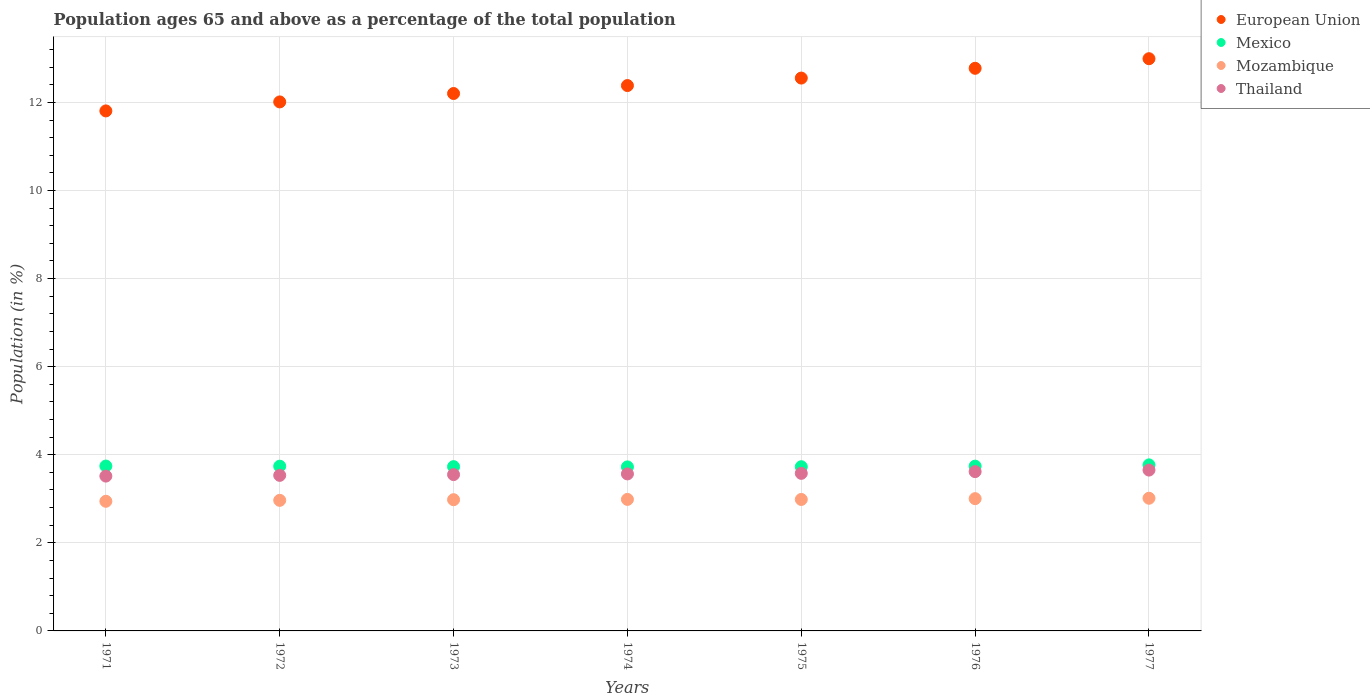What is the percentage of the population ages 65 and above in Thailand in 1971?
Give a very brief answer. 3.52. Across all years, what is the maximum percentage of the population ages 65 and above in Mozambique?
Give a very brief answer. 3.01. Across all years, what is the minimum percentage of the population ages 65 and above in Mozambique?
Ensure brevity in your answer.  2.94. In which year was the percentage of the population ages 65 and above in European Union maximum?
Make the answer very short. 1977. What is the total percentage of the population ages 65 and above in European Union in the graph?
Ensure brevity in your answer.  86.72. What is the difference between the percentage of the population ages 65 and above in Mexico in 1971 and that in 1976?
Keep it short and to the point. 0. What is the difference between the percentage of the population ages 65 and above in Mexico in 1973 and the percentage of the population ages 65 and above in Thailand in 1974?
Provide a succinct answer. 0.17. What is the average percentage of the population ages 65 and above in European Union per year?
Provide a succinct answer. 12.39. In the year 1971, what is the difference between the percentage of the population ages 65 and above in European Union and percentage of the population ages 65 and above in Thailand?
Offer a very short reply. 8.29. In how many years, is the percentage of the population ages 65 and above in European Union greater than 5.6?
Provide a succinct answer. 7. What is the ratio of the percentage of the population ages 65 and above in Mozambique in 1971 to that in 1977?
Your answer should be very brief. 0.98. Is the percentage of the population ages 65 and above in Mozambique in 1971 less than that in 1972?
Keep it short and to the point. Yes. What is the difference between the highest and the second highest percentage of the population ages 65 and above in Thailand?
Offer a terse response. 0.03. What is the difference between the highest and the lowest percentage of the population ages 65 and above in European Union?
Make the answer very short. 1.19. In how many years, is the percentage of the population ages 65 and above in Thailand greater than the average percentage of the population ages 65 and above in Thailand taken over all years?
Your response must be concise. 3. Is the percentage of the population ages 65 and above in Thailand strictly greater than the percentage of the population ages 65 and above in European Union over the years?
Give a very brief answer. No. Is the percentage of the population ages 65 and above in European Union strictly less than the percentage of the population ages 65 and above in Mozambique over the years?
Your answer should be compact. No. How many years are there in the graph?
Your response must be concise. 7. What is the difference between two consecutive major ticks on the Y-axis?
Provide a short and direct response. 2. Are the values on the major ticks of Y-axis written in scientific E-notation?
Your answer should be very brief. No. Does the graph contain grids?
Offer a very short reply. Yes. Where does the legend appear in the graph?
Ensure brevity in your answer.  Top right. How many legend labels are there?
Give a very brief answer. 4. How are the legend labels stacked?
Your answer should be compact. Vertical. What is the title of the graph?
Give a very brief answer. Population ages 65 and above as a percentage of the total population. Does "Macedonia" appear as one of the legend labels in the graph?
Make the answer very short. No. What is the Population (in %) of European Union in 1971?
Give a very brief answer. 11.81. What is the Population (in %) in Mexico in 1971?
Your answer should be compact. 3.74. What is the Population (in %) in Mozambique in 1971?
Your response must be concise. 2.94. What is the Population (in %) of Thailand in 1971?
Your answer should be compact. 3.52. What is the Population (in %) in European Union in 1972?
Make the answer very short. 12.01. What is the Population (in %) in Mexico in 1972?
Your answer should be very brief. 3.74. What is the Population (in %) in Mozambique in 1972?
Ensure brevity in your answer.  2.96. What is the Population (in %) of Thailand in 1972?
Your response must be concise. 3.53. What is the Population (in %) in European Union in 1973?
Your response must be concise. 12.2. What is the Population (in %) in Mexico in 1973?
Offer a terse response. 3.73. What is the Population (in %) of Mozambique in 1973?
Ensure brevity in your answer.  2.98. What is the Population (in %) of Thailand in 1973?
Keep it short and to the point. 3.55. What is the Population (in %) in European Union in 1974?
Your answer should be compact. 12.38. What is the Population (in %) of Mexico in 1974?
Provide a short and direct response. 3.72. What is the Population (in %) in Mozambique in 1974?
Ensure brevity in your answer.  2.99. What is the Population (in %) of Thailand in 1974?
Your answer should be very brief. 3.56. What is the Population (in %) in European Union in 1975?
Your answer should be compact. 12.55. What is the Population (in %) in Mexico in 1975?
Offer a very short reply. 3.73. What is the Population (in %) of Mozambique in 1975?
Ensure brevity in your answer.  2.99. What is the Population (in %) in Thailand in 1975?
Make the answer very short. 3.58. What is the Population (in %) in European Union in 1976?
Ensure brevity in your answer.  12.77. What is the Population (in %) in Mexico in 1976?
Offer a terse response. 3.74. What is the Population (in %) in Mozambique in 1976?
Provide a succinct answer. 3. What is the Population (in %) of Thailand in 1976?
Offer a terse response. 3.62. What is the Population (in %) of European Union in 1977?
Provide a short and direct response. 12.99. What is the Population (in %) of Mexico in 1977?
Give a very brief answer. 3.77. What is the Population (in %) in Mozambique in 1977?
Offer a terse response. 3.01. What is the Population (in %) of Thailand in 1977?
Your answer should be compact. 3.65. Across all years, what is the maximum Population (in %) in European Union?
Provide a succinct answer. 12.99. Across all years, what is the maximum Population (in %) in Mexico?
Your answer should be compact. 3.77. Across all years, what is the maximum Population (in %) in Mozambique?
Ensure brevity in your answer.  3.01. Across all years, what is the maximum Population (in %) of Thailand?
Your response must be concise. 3.65. Across all years, what is the minimum Population (in %) of European Union?
Your answer should be very brief. 11.81. Across all years, what is the minimum Population (in %) of Mexico?
Keep it short and to the point. 3.72. Across all years, what is the minimum Population (in %) in Mozambique?
Give a very brief answer. 2.94. Across all years, what is the minimum Population (in %) of Thailand?
Give a very brief answer. 3.52. What is the total Population (in %) of European Union in the graph?
Offer a terse response. 86.72. What is the total Population (in %) of Mexico in the graph?
Offer a terse response. 26.18. What is the total Population (in %) in Mozambique in the graph?
Make the answer very short. 20.87. What is the total Population (in %) in Thailand in the graph?
Give a very brief answer. 25.01. What is the difference between the Population (in %) in European Union in 1971 and that in 1972?
Provide a short and direct response. -0.2. What is the difference between the Population (in %) of Mexico in 1971 and that in 1972?
Provide a succinct answer. 0. What is the difference between the Population (in %) in Mozambique in 1971 and that in 1972?
Offer a very short reply. -0.02. What is the difference between the Population (in %) in Thailand in 1971 and that in 1972?
Offer a very short reply. -0.02. What is the difference between the Population (in %) in European Union in 1971 and that in 1973?
Your response must be concise. -0.4. What is the difference between the Population (in %) of Mexico in 1971 and that in 1973?
Offer a terse response. 0.01. What is the difference between the Population (in %) of Mozambique in 1971 and that in 1973?
Your response must be concise. -0.04. What is the difference between the Population (in %) in Thailand in 1971 and that in 1973?
Your response must be concise. -0.03. What is the difference between the Population (in %) in European Union in 1971 and that in 1974?
Provide a succinct answer. -0.58. What is the difference between the Population (in %) of Mexico in 1971 and that in 1974?
Keep it short and to the point. 0.02. What is the difference between the Population (in %) of Mozambique in 1971 and that in 1974?
Provide a short and direct response. -0.04. What is the difference between the Population (in %) of Thailand in 1971 and that in 1974?
Your answer should be compact. -0.05. What is the difference between the Population (in %) in European Union in 1971 and that in 1975?
Your response must be concise. -0.75. What is the difference between the Population (in %) in Mexico in 1971 and that in 1975?
Provide a short and direct response. 0.02. What is the difference between the Population (in %) of Mozambique in 1971 and that in 1975?
Provide a succinct answer. -0.04. What is the difference between the Population (in %) in Thailand in 1971 and that in 1975?
Give a very brief answer. -0.06. What is the difference between the Population (in %) in European Union in 1971 and that in 1976?
Your answer should be very brief. -0.97. What is the difference between the Population (in %) in Mexico in 1971 and that in 1976?
Provide a short and direct response. 0. What is the difference between the Population (in %) of Mozambique in 1971 and that in 1976?
Your answer should be compact. -0.06. What is the difference between the Population (in %) of Thailand in 1971 and that in 1976?
Keep it short and to the point. -0.1. What is the difference between the Population (in %) in European Union in 1971 and that in 1977?
Make the answer very short. -1.19. What is the difference between the Population (in %) in Mexico in 1971 and that in 1977?
Make the answer very short. -0.03. What is the difference between the Population (in %) in Mozambique in 1971 and that in 1977?
Your answer should be very brief. -0.07. What is the difference between the Population (in %) in Thailand in 1971 and that in 1977?
Make the answer very short. -0.14. What is the difference between the Population (in %) of European Union in 1972 and that in 1973?
Make the answer very short. -0.19. What is the difference between the Population (in %) in Mexico in 1972 and that in 1973?
Your response must be concise. 0.01. What is the difference between the Population (in %) in Mozambique in 1972 and that in 1973?
Your answer should be compact. -0.01. What is the difference between the Population (in %) of Thailand in 1972 and that in 1973?
Your answer should be very brief. -0.02. What is the difference between the Population (in %) in European Union in 1972 and that in 1974?
Keep it short and to the point. -0.37. What is the difference between the Population (in %) of Mexico in 1972 and that in 1974?
Offer a very short reply. 0.02. What is the difference between the Population (in %) in Mozambique in 1972 and that in 1974?
Your answer should be very brief. -0.02. What is the difference between the Population (in %) in Thailand in 1972 and that in 1974?
Your answer should be compact. -0.03. What is the difference between the Population (in %) in European Union in 1972 and that in 1975?
Provide a short and direct response. -0.54. What is the difference between the Population (in %) of Mexico in 1972 and that in 1975?
Provide a short and direct response. 0.01. What is the difference between the Population (in %) in Mozambique in 1972 and that in 1975?
Keep it short and to the point. -0.02. What is the difference between the Population (in %) in Thailand in 1972 and that in 1975?
Offer a terse response. -0.05. What is the difference between the Population (in %) of European Union in 1972 and that in 1976?
Keep it short and to the point. -0.76. What is the difference between the Population (in %) of Mexico in 1972 and that in 1976?
Offer a terse response. -0. What is the difference between the Population (in %) of Mozambique in 1972 and that in 1976?
Offer a very short reply. -0.04. What is the difference between the Population (in %) in Thailand in 1972 and that in 1976?
Make the answer very short. -0.09. What is the difference between the Population (in %) of European Union in 1972 and that in 1977?
Ensure brevity in your answer.  -0.98. What is the difference between the Population (in %) of Mexico in 1972 and that in 1977?
Your response must be concise. -0.03. What is the difference between the Population (in %) in Mozambique in 1972 and that in 1977?
Your response must be concise. -0.05. What is the difference between the Population (in %) of Thailand in 1972 and that in 1977?
Give a very brief answer. -0.12. What is the difference between the Population (in %) of European Union in 1973 and that in 1974?
Offer a terse response. -0.18. What is the difference between the Population (in %) in Mexico in 1973 and that in 1974?
Ensure brevity in your answer.  0.01. What is the difference between the Population (in %) of Mozambique in 1973 and that in 1974?
Keep it short and to the point. -0.01. What is the difference between the Population (in %) in Thailand in 1973 and that in 1974?
Offer a very short reply. -0.02. What is the difference between the Population (in %) in European Union in 1973 and that in 1975?
Provide a short and direct response. -0.35. What is the difference between the Population (in %) of Mexico in 1973 and that in 1975?
Keep it short and to the point. 0. What is the difference between the Population (in %) of Mozambique in 1973 and that in 1975?
Give a very brief answer. -0.01. What is the difference between the Population (in %) of Thailand in 1973 and that in 1975?
Your answer should be very brief. -0.03. What is the difference between the Population (in %) in European Union in 1973 and that in 1976?
Offer a very short reply. -0.57. What is the difference between the Population (in %) of Mexico in 1973 and that in 1976?
Keep it short and to the point. -0.01. What is the difference between the Population (in %) of Mozambique in 1973 and that in 1976?
Ensure brevity in your answer.  -0.02. What is the difference between the Population (in %) of Thailand in 1973 and that in 1976?
Offer a very short reply. -0.07. What is the difference between the Population (in %) of European Union in 1973 and that in 1977?
Make the answer very short. -0.79. What is the difference between the Population (in %) in Mexico in 1973 and that in 1977?
Offer a very short reply. -0.04. What is the difference between the Population (in %) in Mozambique in 1973 and that in 1977?
Your answer should be very brief. -0.03. What is the difference between the Population (in %) of Thailand in 1973 and that in 1977?
Ensure brevity in your answer.  -0.1. What is the difference between the Population (in %) of European Union in 1974 and that in 1975?
Make the answer very short. -0.17. What is the difference between the Population (in %) in Mexico in 1974 and that in 1975?
Provide a short and direct response. -0. What is the difference between the Population (in %) of Mozambique in 1974 and that in 1975?
Your answer should be very brief. 0. What is the difference between the Population (in %) of Thailand in 1974 and that in 1975?
Ensure brevity in your answer.  -0.01. What is the difference between the Population (in %) of European Union in 1974 and that in 1976?
Your response must be concise. -0.39. What is the difference between the Population (in %) in Mexico in 1974 and that in 1976?
Your response must be concise. -0.02. What is the difference between the Population (in %) in Mozambique in 1974 and that in 1976?
Provide a succinct answer. -0.02. What is the difference between the Population (in %) in Thailand in 1974 and that in 1976?
Ensure brevity in your answer.  -0.05. What is the difference between the Population (in %) of European Union in 1974 and that in 1977?
Give a very brief answer. -0.61. What is the difference between the Population (in %) in Mexico in 1974 and that in 1977?
Offer a terse response. -0.05. What is the difference between the Population (in %) in Mozambique in 1974 and that in 1977?
Give a very brief answer. -0.03. What is the difference between the Population (in %) in Thailand in 1974 and that in 1977?
Your answer should be compact. -0.09. What is the difference between the Population (in %) of European Union in 1975 and that in 1976?
Offer a very short reply. -0.22. What is the difference between the Population (in %) of Mexico in 1975 and that in 1976?
Ensure brevity in your answer.  -0.01. What is the difference between the Population (in %) of Mozambique in 1975 and that in 1976?
Make the answer very short. -0.02. What is the difference between the Population (in %) in Thailand in 1975 and that in 1976?
Offer a terse response. -0.04. What is the difference between the Population (in %) of European Union in 1975 and that in 1977?
Your response must be concise. -0.44. What is the difference between the Population (in %) of Mexico in 1975 and that in 1977?
Provide a succinct answer. -0.04. What is the difference between the Population (in %) in Mozambique in 1975 and that in 1977?
Your answer should be compact. -0.03. What is the difference between the Population (in %) in Thailand in 1975 and that in 1977?
Offer a very short reply. -0.07. What is the difference between the Population (in %) of European Union in 1976 and that in 1977?
Offer a terse response. -0.22. What is the difference between the Population (in %) in Mexico in 1976 and that in 1977?
Ensure brevity in your answer.  -0.03. What is the difference between the Population (in %) in Mozambique in 1976 and that in 1977?
Give a very brief answer. -0.01. What is the difference between the Population (in %) of Thailand in 1976 and that in 1977?
Your answer should be compact. -0.04. What is the difference between the Population (in %) of European Union in 1971 and the Population (in %) of Mexico in 1972?
Keep it short and to the point. 8.07. What is the difference between the Population (in %) in European Union in 1971 and the Population (in %) in Mozambique in 1972?
Provide a short and direct response. 8.84. What is the difference between the Population (in %) in European Union in 1971 and the Population (in %) in Thailand in 1972?
Offer a very short reply. 8.28. What is the difference between the Population (in %) in Mexico in 1971 and the Population (in %) in Mozambique in 1972?
Give a very brief answer. 0.78. What is the difference between the Population (in %) in Mexico in 1971 and the Population (in %) in Thailand in 1972?
Offer a very short reply. 0.21. What is the difference between the Population (in %) of Mozambique in 1971 and the Population (in %) of Thailand in 1972?
Make the answer very short. -0.59. What is the difference between the Population (in %) of European Union in 1971 and the Population (in %) of Mexico in 1973?
Your response must be concise. 8.08. What is the difference between the Population (in %) of European Union in 1971 and the Population (in %) of Mozambique in 1973?
Your answer should be compact. 8.83. What is the difference between the Population (in %) in European Union in 1971 and the Population (in %) in Thailand in 1973?
Make the answer very short. 8.26. What is the difference between the Population (in %) of Mexico in 1971 and the Population (in %) of Mozambique in 1973?
Provide a short and direct response. 0.76. What is the difference between the Population (in %) of Mexico in 1971 and the Population (in %) of Thailand in 1973?
Offer a very short reply. 0.19. What is the difference between the Population (in %) in Mozambique in 1971 and the Population (in %) in Thailand in 1973?
Your response must be concise. -0.61. What is the difference between the Population (in %) of European Union in 1971 and the Population (in %) of Mexico in 1974?
Provide a succinct answer. 8.08. What is the difference between the Population (in %) in European Union in 1971 and the Population (in %) in Mozambique in 1974?
Offer a terse response. 8.82. What is the difference between the Population (in %) in European Union in 1971 and the Population (in %) in Thailand in 1974?
Offer a very short reply. 8.24. What is the difference between the Population (in %) of Mexico in 1971 and the Population (in %) of Mozambique in 1974?
Your answer should be compact. 0.76. What is the difference between the Population (in %) in Mexico in 1971 and the Population (in %) in Thailand in 1974?
Your response must be concise. 0.18. What is the difference between the Population (in %) of Mozambique in 1971 and the Population (in %) of Thailand in 1974?
Give a very brief answer. -0.62. What is the difference between the Population (in %) in European Union in 1971 and the Population (in %) in Mexico in 1975?
Keep it short and to the point. 8.08. What is the difference between the Population (in %) in European Union in 1971 and the Population (in %) in Mozambique in 1975?
Your answer should be very brief. 8.82. What is the difference between the Population (in %) of European Union in 1971 and the Population (in %) of Thailand in 1975?
Your response must be concise. 8.23. What is the difference between the Population (in %) of Mexico in 1971 and the Population (in %) of Mozambique in 1975?
Your answer should be very brief. 0.76. What is the difference between the Population (in %) in Mexico in 1971 and the Population (in %) in Thailand in 1975?
Provide a succinct answer. 0.17. What is the difference between the Population (in %) in Mozambique in 1971 and the Population (in %) in Thailand in 1975?
Ensure brevity in your answer.  -0.63. What is the difference between the Population (in %) in European Union in 1971 and the Population (in %) in Mexico in 1976?
Your answer should be compact. 8.07. What is the difference between the Population (in %) of European Union in 1971 and the Population (in %) of Mozambique in 1976?
Offer a terse response. 8.8. What is the difference between the Population (in %) in European Union in 1971 and the Population (in %) in Thailand in 1976?
Your response must be concise. 8.19. What is the difference between the Population (in %) of Mexico in 1971 and the Population (in %) of Mozambique in 1976?
Give a very brief answer. 0.74. What is the difference between the Population (in %) of Mexico in 1971 and the Population (in %) of Thailand in 1976?
Provide a short and direct response. 0.13. What is the difference between the Population (in %) of Mozambique in 1971 and the Population (in %) of Thailand in 1976?
Keep it short and to the point. -0.67. What is the difference between the Population (in %) of European Union in 1971 and the Population (in %) of Mexico in 1977?
Ensure brevity in your answer.  8.04. What is the difference between the Population (in %) of European Union in 1971 and the Population (in %) of Mozambique in 1977?
Keep it short and to the point. 8.79. What is the difference between the Population (in %) in European Union in 1971 and the Population (in %) in Thailand in 1977?
Provide a succinct answer. 8.15. What is the difference between the Population (in %) of Mexico in 1971 and the Population (in %) of Mozambique in 1977?
Provide a short and direct response. 0.73. What is the difference between the Population (in %) of Mexico in 1971 and the Population (in %) of Thailand in 1977?
Offer a terse response. 0.09. What is the difference between the Population (in %) in Mozambique in 1971 and the Population (in %) in Thailand in 1977?
Offer a very short reply. -0.71. What is the difference between the Population (in %) in European Union in 1972 and the Population (in %) in Mexico in 1973?
Ensure brevity in your answer.  8.28. What is the difference between the Population (in %) of European Union in 1972 and the Population (in %) of Mozambique in 1973?
Offer a terse response. 9.03. What is the difference between the Population (in %) of European Union in 1972 and the Population (in %) of Thailand in 1973?
Your answer should be very brief. 8.46. What is the difference between the Population (in %) in Mexico in 1972 and the Population (in %) in Mozambique in 1973?
Provide a succinct answer. 0.76. What is the difference between the Population (in %) of Mexico in 1972 and the Population (in %) of Thailand in 1973?
Your response must be concise. 0.19. What is the difference between the Population (in %) in Mozambique in 1972 and the Population (in %) in Thailand in 1973?
Give a very brief answer. -0.58. What is the difference between the Population (in %) in European Union in 1972 and the Population (in %) in Mexico in 1974?
Your response must be concise. 8.29. What is the difference between the Population (in %) in European Union in 1972 and the Population (in %) in Mozambique in 1974?
Your response must be concise. 9.03. What is the difference between the Population (in %) of European Union in 1972 and the Population (in %) of Thailand in 1974?
Ensure brevity in your answer.  8.45. What is the difference between the Population (in %) of Mexico in 1972 and the Population (in %) of Mozambique in 1974?
Make the answer very short. 0.75. What is the difference between the Population (in %) in Mexico in 1972 and the Population (in %) in Thailand in 1974?
Your response must be concise. 0.18. What is the difference between the Population (in %) of Mozambique in 1972 and the Population (in %) of Thailand in 1974?
Ensure brevity in your answer.  -0.6. What is the difference between the Population (in %) of European Union in 1972 and the Population (in %) of Mexico in 1975?
Provide a succinct answer. 8.28. What is the difference between the Population (in %) of European Union in 1972 and the Population (in %) of Mozambique in 1975?
Provide a succinct answer. 9.03. What is the difference between the Population (in %) in European Union in 1972 and the Population (in %) in Thailand in 1975?
Keep it short and to the point. 8.43. What is the difference between the Population (in %) of Mexico in 1972 and the Population (in %) of Mozambique in 1975?
Offer a terse response. 0.76. What is the difference between the Population (in %) in Mexico in 1972 and the Population (in %) in Thailand in 1975?
Provide a short and direct response. 0.16. What is the difference between the Population (in %) of Mozambique in 1972 and the Population (in %) of Thailand in 1975?
Your answer should be very brief. -0.61. What is the difference between the Population (in %) in European Union in 1972 and the Population (in %) in Mexico in 1976?
Offer a terse response. 8.27. What is the difference between the Population (in %) of European Union in 1972 and the Population (in %) of Mozambique in 1976?
Your answer should be very brief. 9.01. What is the difference between the Population (in %) in European Union in 1972 and the Population (in %) in Thailand in 1976?
Offer a terse response. 8.39. What is the difference between the Population (in %) in Mexico in 1972 and the Population (in %) in Mozambique in 1976?
Your answer should be compact. 0.74. What is the difference between the Population (in %) of Mexico in 1972 and the Population (in %) of Thailand in 1976?
Keep it short and to the point. 0.12. What is the difference between the Population (in %) of Mozambique in 1972 and the Population (in %) of Thailand in 1976?
Ensure brevity in your answer.  -0.65. What is the difference between the Population (in %) in European Union in 1972 and the Population (in %) in Mexico in 1977?
Your answer should be very brief. 8.24. What is the difference between the Population (in %) of European Union in 1972 and the Population (in %) of Mozambique in 1977?
Your answer should be compact. 9. What is the difference between the Population (in %) of European Union in 1972 and the Population (in %) of Thailand in 1977?
Ensure brevity in your answer.  8.36. What is the difference between the Population (in %) in Mexico in 1972 and the Population (in %) in Mozambique in 1977?
Make the answer very short. 0.73. What is the difference between the Population (in %) in Mexico in 1972 and the Population (in %) in Thailand in 1977?
Your response must be concise. 0.09. What is the difference between the Population (in %) in Mozambique in 1972 and the Population (in %) in Thailand in 1977?
Ensure brevity in your answer.  -0.69. What is the difference between the Population (in %) in European Union in 1973 and the Population (in %) in Mexico in 1974?
Your response must be concise. 8.48. What is the difference between the Population (in %) in European Union in 1973 and the Population (in %) in Mozambique in 1974?
Your answer should be very brief. 9.22. What is the difference between the Population (in %) in European Union in 1973 and the Population (in %) in Thailand in 1974?
Your answer should be very brief. 8.64. What is the difference between the Population (in %) in Mexico in 1973 and the Population (in %) in Mozambique in 1974?
Your answer should be compact. 0.74. What is the difference between the Population (in %) in Mexico in 1973 and the Population (in %) in Thailand in 1974?
Ensure brevity in your answer.  0.17. What is the difference between the Population (in %) in Mozambique in 1973 and the Population (in %) in Thailand in 1974?
Keep it short and to the point. -0.59. What is the difference between the Population (in %) in European Union in 1973 and the Population (in %) in Mexico in 1975?
Ensure brevity in your answer.  8.47. What is the difference between the Population (in %) of European Union in 1973 and the Population (in %) of Mozambique in 1975?
Your response must be concise. 9.22. What is the difference between the Population (in %) of European Union in 1973 and the Population (in %) of Thailand in 1975?
Ensure brevity in your answer.  8.62. What is the difference between the Population (in %) in Mexico in 1973 and the Population (in %) in Mozambique in 1975?
Give a very brief answer. 0.74. What is the difference between the Population (in %) in Mexico in 1973 and the Population (in %) in Thailand in 1975?
Your response must be concise. 0.15. What is the difference between the Population (in %) in Mozambique in 1973 and the Population (in %) in Thailand in 1975?
Offer a terse response. -0.6. What is the difference between the Population (in %) of European Union in 1973 and the Population (in %) of Mexico in 1976?
Your answer should be compact. 8.46. What is the difference between the Population (in %) in European Union in 1973 and the Population (in %) in Mozambique in 1976?
Provide a succinct answer. 9.2. What is the difference between the Population (in %) in European Union in 1973 and the Population (in %) in Thailand in 1976?
Your answer should be compact. 8.59. What is the difference between the Population (in %) in Mexico in 1973 and the Population (in %) in Mozambique in 1976?
Provide a short and direct response. 0.73. What is the difference between the Population (in %) in Mexico in 1973 and the Population (in %) in Thailand in 1976?
Your answer should be very brief. 0.11. What is the difference between the Population (in %) of Mozambique in 1973 and the Population (in %) of Thailand in 1976?
Keep it short and to the point. -0.64. What is the difference between the Population (in %) in European Union in 1973 and the Population (in %) in Mexico in 1977?
Your answer should be very brief. 8.43. What is the difference between the Population (in %) of European Union in 1973 and the Population (in %) of Mozambique in 1977?
Your answer should be very brief. 9.19. What is the difference between the Population (in %) of European Union in 1973 and the Population (in %) of Thailand in 1977?
Your response must be concise. 8.55. What is the difference between the Population (in %) in Mexico in 1973 and the Population (in %) in Mozambique in 1977?
Provide a succinct answer. 0.72. What is the difference between the Population (in %) of Mexico in 1973 and the Population (in %) of Thailand in 1977?
Provide a succinct answer. 0.08. What is the difference between the Population (in %) in Mozambique in 1973 and the Population (in %) in Thailand in 1977?
Offer a terse response. -0.67. What is the difference between the Population (in %) in European Union in 1974 and the Population (in %) in Mexico in 1975?
Your answer should be compact. 8.65. What is the difference between the Population (in %) of European Union in 1974 and the Population (in %) of Mozambique in 1975?
Your answer should be compact. 9.4. What is the difference between the Population (in %) of European Union in 1974 and the Population (in %) of Thailand in 1975?
Offer a very short reply. 8.8. What is the difference between the Population (in %) of Mexico in 1974 and the Population (in %) of Mozambique in 1975?
Provide a succinct answer. 0.74. What is the difference between the Population (in %) of Mexico in 1974 and the Population (in %) of Thailand in 1975?
Give a very brief answer. 0.15. What is the difference between the Population (in %) in Mozambique in 1974 and the Population (in %) in Thailand in 1975?
Your answer should be compact. -0.59. What is the difference between the Population (in %) in European Union in 1974 and the Population (in %) in Mexico in 1976?
Ensure brevity in your answer.  8.64. What is the difference between the Population (in %) of European Union in 1974 and the Population (in %) of Mozambique in 1976?
Provide a short and direct response. 9.38. What is the difference between the Population (in %) of European Union in 1974 and the Population (in %) of Thailand in 1976?
Make the answer very short. 8.77. What is the difference between the Population (in %) in Mexico in 1974 and the Population (in %) in Mozambique in 1976?
Offer a terse response. 0.72. What is the difference between the Population (in %) of Mexico in 1974 and the Population (in %) of Thailand in 1976?
Keep it short and to the point. 0.11. What is the difference between the Population (in %) of Mozambique in 1974 and the Population (in %) of Thailand in 1976?
Your answer should be compact. -0.63. What is the difference between the Population (in %) of European Union in 1974 and the Population (in %) of Mexico in 1977?
Your answer should be very brief. 8.61. What is the difference between the Population (in %) in European Union in 1974 and the Population (in %) in Mozambique in 1977?
Ensure brevity in your answer.  9.37. What is the difference between the Population (in %) in European Union in 1974 and the Population (in %) in Thailand in 1977?
Provide a succinct answer. 8.73. What is the difference between the Population (in %) of Mexico in 1974 and the Population (in %) of Mozambique in 1977?
Offer a very short reply. 0.71. What is the difference between the Population (in %) of Mexico in 1974 and the Population (in %) of Thailand in 1977?
Your answer should be very brief. 0.07. What is the difference between the Population (in %) in Mozambique in 1974 and the Population (in %) in Thailand in 1977?
Give a very brief answer. -0.67. What is the difference between the Population (in %) of European Union in 1975 and the Population (in %) of Mexico in 1976?
Your response must be concise. 8.81. What is the difference between the Population (in %) in European Union in 1975 and the Population (in %) in Mozambique in 1976?
Give a very brief answer. 9.55. What is the difference between the Population (in %) in European Union in 1975 and the Population (in %) in Thailand in 1976?
Give a very brief answer. 8.94. What is the difference between the Population (in %) in Mexico in 1975 and the Population (in %) in Mozambique in 1976?
Ensure brevity in your answer.  0.72. What is the difference between the Population (in %) in Mexico in 1975 and the Population (in %) in Thailand in 1976?
Offer a terse response. 0.11. What is the difference between the Population (in %) of Mozambique in 1975 and the Population (in %) of Thailand in 1976?
Keep it short and to the point. -0.63. What is the difference between the Population (in %) in European Union in 1975 and the Population (in %) in Mexico in 1977?
Keep it short and to the point. 8.78. What is the difference between the Population (in %) in European Union in 1975 and the Population (in %) in Mozambique in 1977?
Keep it short and to the point. 9.54. What is the difference between the Population (in %) of European Union in 1975 and the Population (in %) of Thailand in 1977?
Ensure brevity in your answer.  8.9. What is the difference between the Population (in %) of Mexico in 1975 and the Population (in %) of Mozambique in 1977?
Provide a short and direct response. 0.72. What is the difference between the Population (in %) in Mexico in 1975 and the Population (in %) in Thailand in 1977?
Offer a terse response. 0.08. What is the difference between the Population (in %) in Mozambique in 1975 and the Population (in %) in Thailand in 1977?
Make the answer very short. -0.67. What is the difference between the Population (in %) in European Union in 1976 and the Population (in %) in Mexico in 1977?
Provide a short and direct response. 9. What is the difference between the Population (in %) of European Union in 1976 and the Population (in %) of Mozambique in 1977?
Make the answer very short. 9.76. What is the difference between the Population (in %) in European Union in 1976 and the Population (in %) in Thailand in 1977?
Your answer should be compact. 9.12. What is the difference between the Population (in %) in Mexico in 1976 and the Population (in %) in Mozambique in 1977?
Ensure brevity in your answer.  0.73. What is the difference between the Population (in %) in Mexico in 1976 and the Population (in %) in Thailand in 1977?
Provide a succinct answer. 0.09. What is the difference between the Population (in %) of Mozambique in 1976 and the Population (in %) of Thailand in 1977?
Give a very brief answer. -0.65. What is the average Population (in %) of European Union per year?
Give a very brief answer. 12.39. What is the average Population (in %) in Mexico per year?
Your response must be concise. 3.74. What is the average Population (in %) of Mozambique per year?
Offer a terse response. 2.98. What is the average Population (in %) of Thailand per year?
Ensure brevity in your answer.  3.57. In the year 1971, what is the difference between the Population (in %) of European Union and Population (in %) of Mexico?
Offer a terse response. 8.06. In the year 1971, what is the difference between the Population (in %) in European Union and Population (in %) in Mozambique?
Offer a very short reply. 8.86. In the year 1971, what is the difference between the Population (in %) in European Union and Population (in %) in Thailand?
Your answer should be very brief. 8.29. In the year 1971, what is the difference between the Population (in %) in Mexico and Population (in %) in Mozambique?
Offer a very short reply. 0.8. In the year 1971, what is the difference between the Population (in %) of Mexico and Population (in %) of Thailand?
Give a very brief answer. 0.23. In the year 1971, what is the difference between the Population (in %) in Mozambique and Population (in %) in Thailand?
Offer a terse response. -0.57. In the year 1972, what is the difference between the Population (in %) in European Union and Population (in %) in Mexico?
Offer a terse response. 8.27. In the year 1972, what is the difference between the Population (in %) of European Union and Population (in %) of Mozambique?
Your answer should be compact. 9.05. In the year 1972, what is the difference between the Population (in %) of European Union and Population (in %) of Thailand?
Your answer should be very brief. 8.48. In the year 1972, what is the difference between the Population (in %) of Mexico and Population (in %) of Mozambique?
Your response must be concise. 0.78. In the year 1972, what is the difference between the Population (in %) in Mexico and Population (in %) in Thailand?
Offer a terse response. 0.21. In the year 1972, what is the difference between the Population (in %) in Mozambique and Population (in %) in Thailand?
Provide a succinct answer. -0.57. In the year 1973, what is the difference between the Population (in %) in European Union and Population (in %) in Mexico?
Offer a very short reply. 8.47. In the year 1973, what is the difference between the Population (in %) in European Union and Population (in %) in Mozambique?
Make the answer very short. 9.22. In the year 1973, what is the difference between the Population (in %) of European Union and Population (in %) of Thailand?
Offer a very short reply. 8.65. In the year 1973, what is the difference between the Population (in %) in Mexico and Population (in %) in Mozambique?
Keep it short and to the point. 0.75. In the year 1973, what is the difference between the Population (in %) in Mexico and Population (in %) in Thailand?
Provide a succinct answer. 0.18. In the year 1973, what is the difference between the Population (in %) of Mozambique and Population (in %) of Thailand?
Make the answer very short. -0.57. In the year 1974, what is the difference between the Population (in %) in European Union and Population (in %) in Mexico?
Offer a very short reply. 8.66. In the year 1974, what is the difference between the Population (in %) of European Union and Population (in %) of Mozambique?
Your response must be concise. 9.4. In the year 1974, what is the difference between the Population (in %) of European Union and Population (in %) of Thailand?
Offer a very short reply. 8.82. In the year 1974, what is the difference between the Population (in %) in Mexico and Population (in %) in Mozambique?
Keep it short and to the point. 0.74. In the year 1974, what is the difference between the Population (in %) in Mexico and Population (in %) in Thailand?
Keep it short and to the point. 0.16. In the year 1974, what is the difference between the Population (in %) in Mozambique and Population (in %) in Thailand?
Ensure brevity in your answer.  -0.58. In the year 1975, what is the difference between the Population (in %) of European Union and Population (in %) of Mexico?
Offer a terse response. 8.82. In the year 1975, what is the difference between the Population (in %) in European Union and Population (in %) in Mozambique?
Provide a short and direct response. 9.57. In the year 1975, what is the difference between the Population (in %) in European Union and Population (in %) in Thailand?
Offer a very short reply. 8.98. In the year 1975, what is the difference between the Population (in %) in Mexico and Population (in %) in Mozambique?
Your answer should be very brief. 0.74. In the year 1975, what is the difference between the Population (in %) of Mexico and Population (in %) of Thailand?
Make the answer very short. 0.15. In the year 1975, what is the difference between the Population (in %) in Mozambique and Population (in %) in Thailand?
Offer a very short reply. -0.59. In the year 1976, what is the difference between the Population (in %) of European Union and Population (in %) of Mexico?
Your response must be concise. 9.03. In the year 1976, what is the difference between the Population (in %) of European Union and Population (in %) of Mozambique?
Provide a succinct answer. 9.77. In the year 1976, what is the difference between the Population (in %) in European Union and Population (in %) in Thailand?
Ensure brevity in your answer.  9.16. In the year 1976, what is the difference between the Population (in %) of Mexico and Population (in %) of Mozambique?
Offer a very short reply. 0.74. In the year 1976, what is the difference between the Population (in %) in Mexico and Population (in %) in Thailand?
Your answer should be compact. 0.12. In the year 1976, what is the difference between the Population (in %) in Mozambique and Population (in %) in Thailand?
Your answer should be compact. -0.61. In the year 1977, what is the difference between the Population (in %) in European Union and Population (in %) in Mexico?
Ensure brevity in your answer.  9.22. In the year 1977, what is the difference between the Population (in %) in European Union and Population (in %) in Mozambique?
Your response must be concise. 9.98. In the year 1977, what is the difference between the Population (in %) of European Union and Population (in %) of Thailand?
Offer a terse response. 9.34. In the year 1977, what is the difference between the Population (in %) of Mexico and Population (in %) of Mozambique?
Ensure brevity in your answer.  0.76. In the year 1977, what is the difference between the Population (in %) in Mexico and Population (in %) in Thailand?
Ensure brevity in your answer.  0.12. In the year 1977, what is the difference between the Population (in %) in Mozambique and Population (in %) in Thailand?
Your answer should be compact. -0.64. What is the ratio of the Population (in %) in Mexico in 1971 to that in 1972?
Make the answer very short. 1. What is the ratio of the Population (in %) in Mozambique in 1971 to that in 1972?
Ensure brevity in your answer.  0.99. What is the ratio of the Population (in %) of European Union in 1971 to that in 1973?
Offer a terse response. 0.97. What is the ratio of the Population (in %) of Mexico in 1971 to that in 1973?
Your answer should be compact. 1. What is the ratio of the Population (in %) in Mozambique in 1971 to that in 1973?
Provide a short and direct response. 0.99. What is the ratio of the Population (in %) of European Union in 1971 to that in 1974?
Offer a very short reply. 0.95. What is the ratio of the Population (in %) of Mexico in 1971 to that in 1974?
Your response must be concise. 1.01. What is the ratio of the Population (in %) in Mozambique in 1971 to that in 1974?
Provide a short and direct response. 0.99. What is the ratio of the Population (in %) of Thailand in 1971 to that in 1974?
Your answer should be compact. 0.99. What is the ratio of the Population (in %) in European Union in 1971 to that in 1975?
Provide a short and direct response. 0.94. What is the ratio of the Population (in %) of Thailand in 1971 to that in 1975?
Your response must be concise. 0.98. What is the ratio of the Population (in %) of European Union in 1971 to that in 1976?
Keep it short and to the point. 0.92. What is the ratio of the Population (in %) in Mexico in 1971 to that in 1976?
Your answer should be very brief. 1. What is the ratio of the Population (in %) of Mozambique in 1971 to that in 1976?
Ensure brevity in your answer.  0.98. What is the ratio of the Population (in %) of Thailand in 1971 to that in 1976?
Ensure brevity in your answer.  0.97. What is the ratio of the Population (in %) of European Union in 1971 to that in 1977?
Keep it short and to the point. 0.91. What is the ratio of the Population (in %) in Mexico in 1971 to that in 1977?
Provide a short and direct response. 0.99. What is the ratio of the Population (in %) in Mozambique in 1971 to that in 1977?
Give a very brief answer. 0.98. What is the ratio of the Population (in %) in Thailand in 1971 to that in 1977?
Keep it short and to the point. 0.96. What is the ratio of the Population (in %) in European Union in 1972 to that in 1973?
Offer a terse response. 0.98. What is the ratio of the Population (in %) of European Union in 1972 to that in 1974?
Your answer should be very brief. 0.97. What is the ratio of the Population (in %) in Mexico in 1972 to that in 1974?
Provide a short and direct response. 1. What is the ratio of the Population (in %) in Mozambique in 1972 to that in 1974?
Provide a succinct answer. 0.99. What is the ratio of the Population (in %) in European Union in 1972 to that in 1975?
Keep it short and to the point. 0.96. What is the ratio of the Population (in %) of Thailand in 1972 to that in 1975?
Make the answer very short. 0.99. What is the ratio of the Population (in %) in European Union in 1972 to that in 1976?
Keep it short and to the point. 0.94. What is the ratio of the Population (in %) of Mexico in 1972 to that in 1976?
Your answer should be compact. 1. What is the ratio of the Population (in %) in Mozambique in 1972 to that in 1976?
Provide a short and direct response. 0.99. What is the ratio of the Population (in %) in Thailand in 1972 to that in 1976?
Offer a terse response. 0.98. What is the ratio of the Population (in %) of European Union in 1972 to that in 1977?
Keep it short and to the point. 0.92. What is the ratio of the Population (in %) in Mozambique in 1972 to that in 1977?
Your answer should be compact. 0.98. What is the ratio of the Population (in %) in Thailand in 1972 to that in 1977?
Your answer should be very brief. 0.97. What is the ratio of the Population (in %) of European Union in 1973 to that in 1974?
Offer a very short reply. 0.99. What is the ratio of the Population (in %) of Mozambique in 1973 to that in 1974?
Provide a succinct answer. 1. What is the ratio of the Population (in %) of Thailand in 1973 to that in 1974?
Provide a short and direct response. 1. What is the ratio of the Population (in %) in European Union in 1973 to that in 1975?
Ensure brevity in your answer.  0.97. What is the ratio of the Population (in %) in European Union in 1973 to that in 1976?
Offer a terse response. 0.96. What is the ratio of the Population (in %) in Mozambique in 1973 to that in 1976?
Your answer should be compact. 0.99. What is the ratio of the Population (in %) in Thailand in 1973 to that in 1976?
Offer a terse response. 0.98. What is the ratio of the Population (in %) of European Union in 1973 to that in 1977?
Your response must be concise. 0.94. What is the ratio of the Population (in %) in Mozambique in 1973 to that in 1977?
Ensure brevity in your answer.  0.99. What is the ratio of the Population (in %) of Thailand in 1973 to that in 1977?
Provide a short and direct response. 0.97. What is the ratio of the Population (in %) in European Union in 1974 to that in 1975?
Your answer should be very brief. 0.99. What is the ratio of the Population (in %) of Mexico in 1974 to that in 1975?
Offer a terse response. 1. What is the ratio of the Population (in %) of Mozambique in 1974 to that in 1975?
Offer a very short reply. 1. What is the ratio of the Population (in %) in Thailand in 1974 to that in 1975?
Give a very brief answer. 1. What is the ratio of the Population (in %) in European Union in 1974 to that in 1976?
Make the answer very short. 0.97. What is the ratio of the Population (in %) of Mozambique in 1974 to that in 1976?
Provide a succinct answer. 0.99. What is the ratio of the Population (in %) of Thailand in 1974 to that in 1976?
Provide a short and direct response. 0.99. What is the ratio of the Population (in %) in European Union in 1974 to that in 1977?
Ensure brevity in your answer.  0.95. What is the ratio of the Population (in %) in Mexico in 1974 to that in 1977?
Provide a short and direct response. 0.99. What is the ratio of the Population (in %) in Mozambique in 1974 to that in 1977?
Your response must be concise. 0.99. What is the ratio of the Population (in %) in Thailand in 1974 to that in 1977?
Provide a short and direct response. 0.98. What is the ratio of the Population (in %) in European Union in 1975 to that in 1976?
Provide a succinct answer. 0.98. What is the ratio of the Population (in %) in Thailand in 1975 to that in 1976?
Offer a very short reply. 0.99. What is the ratio of the Population (in %) in European Union in 1975 to that in 1977?
Give a very brief answer. 0.97. What is the ratio of the Population (in %) in Mexico in 1975 to that in 1977?
Your answer should be very brief. 0.99. What is the ratio of the Population (in %) in Mozambique in 1975 to that in 1977?
Your response must be concise. 0.99. What is the ratio of the Population (in %) of Thailand in 1975 to that in 1977?
Provide a succinct answer. 0.98. What is the ratio of the Population (in %) in European Union in 1976 to that in 1977?
Make the answer very short. 0.98. What is the ratio of the Population (in %) of Mexico in 1976 to that in 1977?
Your answer should be very brief. 0.99. What is the ratio of the Population (in %) in Mozambique in 1976 to that in 1977?
Ensure brevity in your answer.  1. What is the difference between the highest and the second highest Population (in %) of European Union?
Provide a short and direct response. 0.22. What is the difference between the highest and the second highest Population (in %) of Mexico?
Your answer should be very brief. 0.03. What is the difference between the highest and the second highest Population (in %) of Mozambique?
Ensure brevity in your answer.  0.01. What is the difference between the highest and the second highest Population (in %) of Thailand?
Give a very brief answer. 0.04. What is the difference between the highest and the lowest Population (in %) of European Union?
Ensure brevity in your answer.  1.19. What is the difference between the highest and the lowest Population (in %) in Mexico?
Your answer should be compact. 0.05. What is the difference between the highest and the lowest Population (in %) of Mozambique?
Make the answer very short. 0.07. What is the difference between the highest and the lowest Population (in %) of Thailand?
Provide a short and direct response. 0.14. 